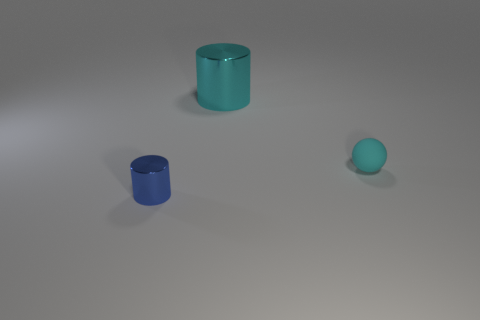Add 2 tiny rubber spheres. How many objects exist? 5 Subtract all cylinders. How many objects are left? 1 Add 2 big metal cylinders. How many big metal cylinders exist? 3 Subtract 0 brown cylinders. How many objects are left? 3 Subtract all large red matte cubes. Subtract all tiny blue objects. How many objects are left? 2 Add 2 tiny cylinders. How many tiny cylinders are left? 3 